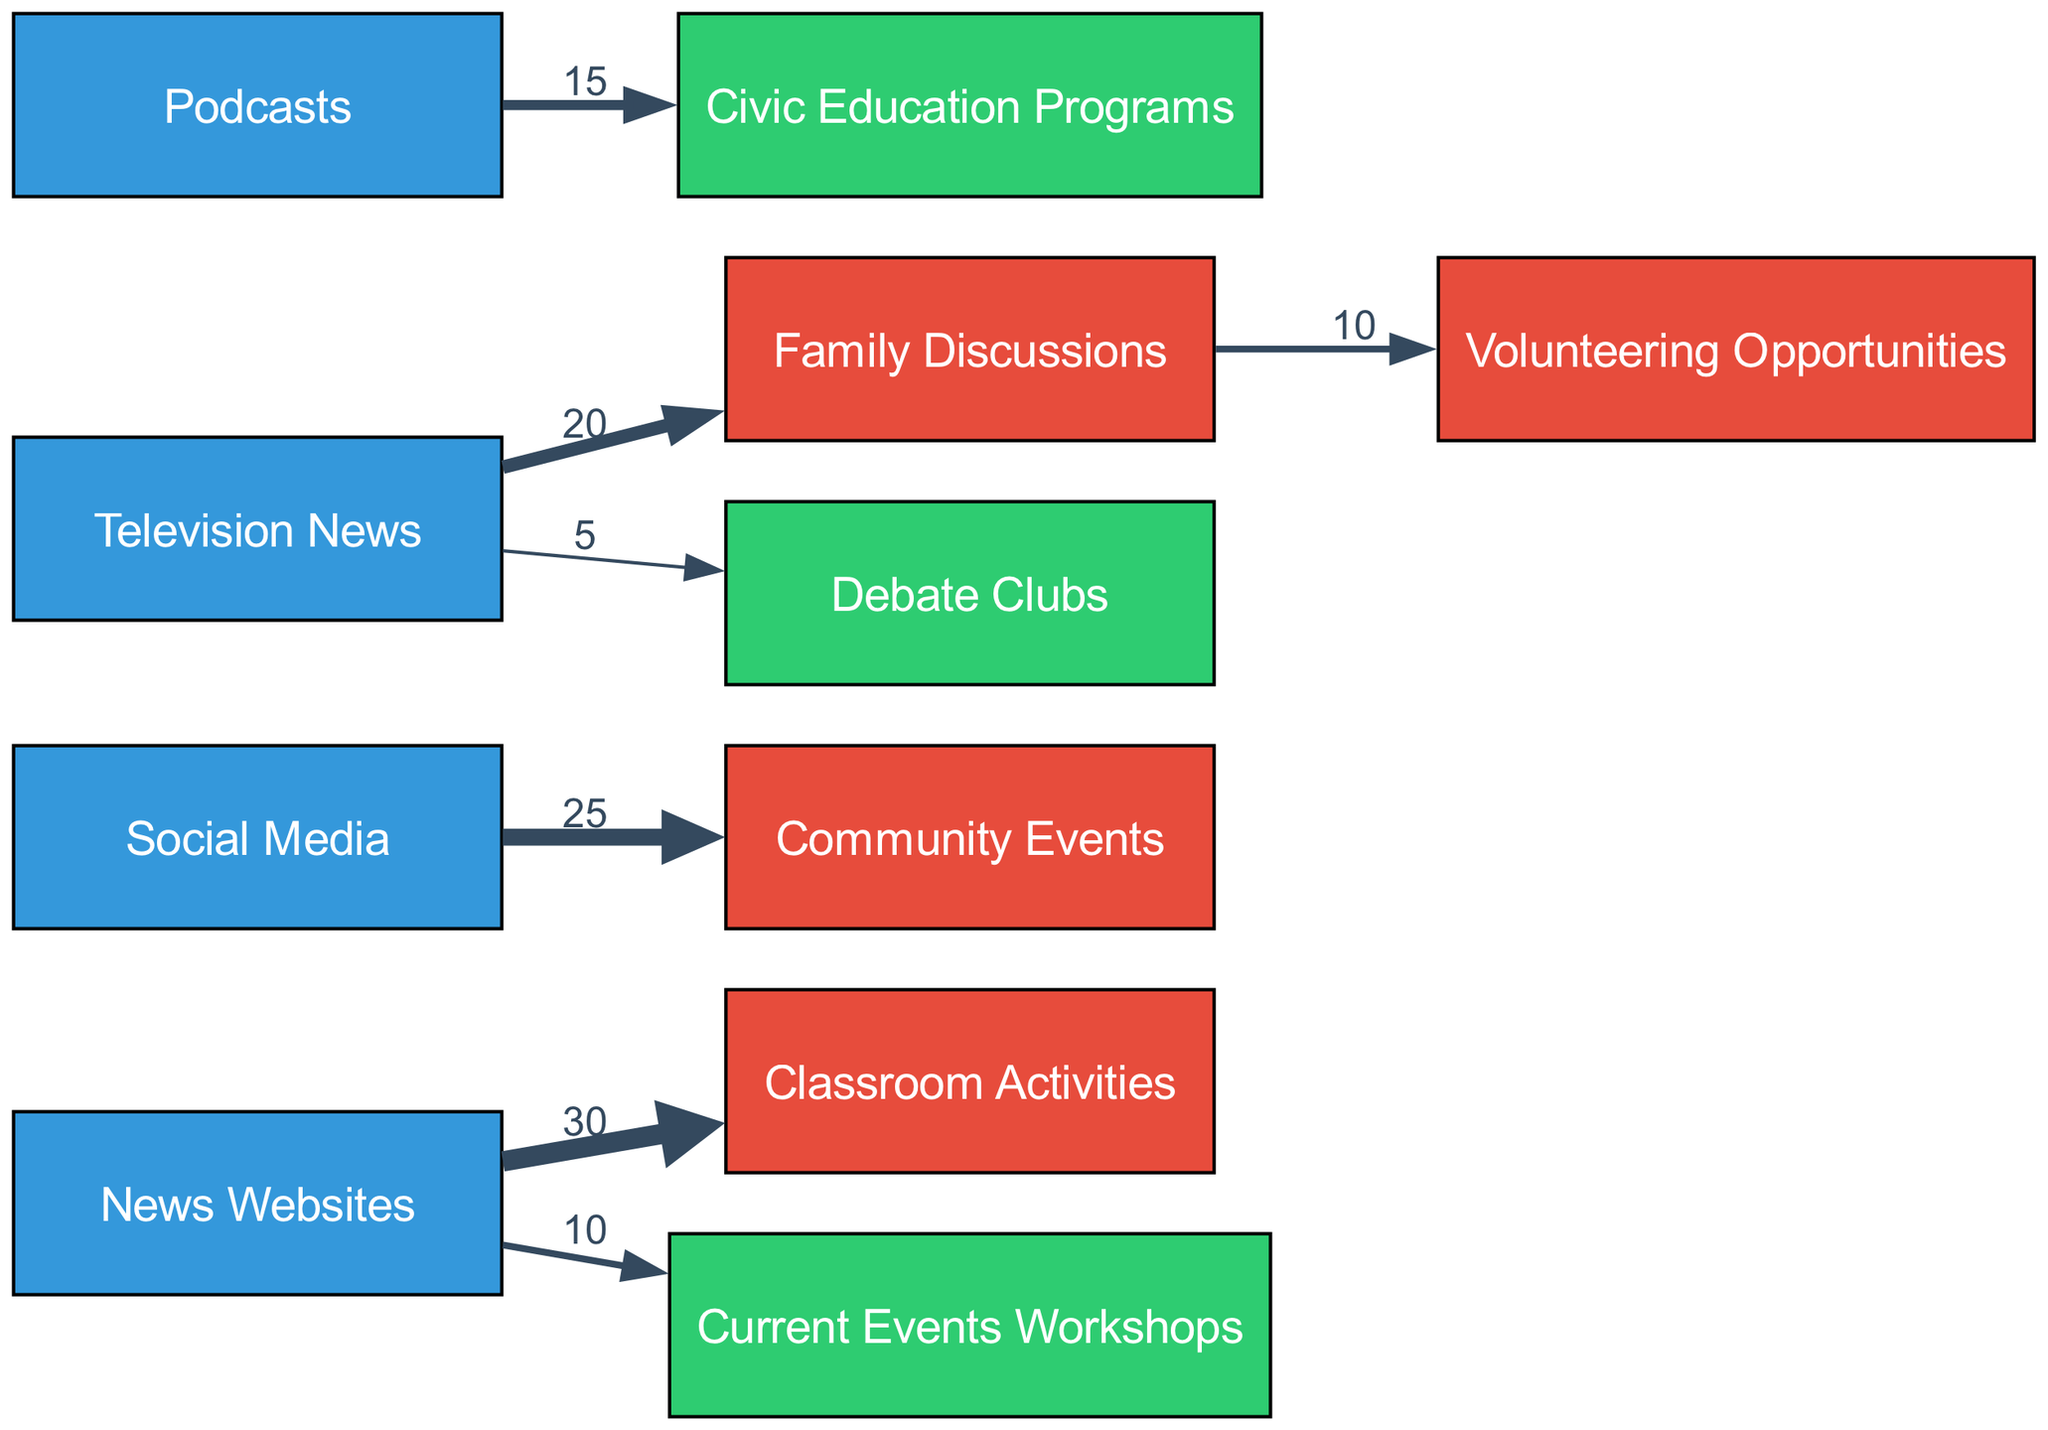what is the value connecting News Websites to Classroom Activities? In the diagram, the link from "News Websites" to "Classroom Activities" has a value label of 30, indicating that 30 units of media consumption flow from this source to this engagement type.
Answer: 30 how many engagement types are shown in the diagram? The diagram includes four engagement types: Classroom Activities, Community Events, Family Discussions, and Volunteering Opportunities. Therefore, by counting these unique nodes under the "Engagement" category, we find there are four engagement types.
Answer: 4 which source connects to the highest number of engagement activities? By examining the sources in the diagram, "News Websites" is linked to both "Classroom Activities" (30) and "Current Events Workshops" (10), totaling two engagement activities, while "Social Media," "Television News," and "Podcasts" are each connected to one or two activities. The highest number of connections to engagement activities is from "News Websites."
Answer: News Websites what is the total value of all connections to Family Discussions? The diagram shows that "Family Discussions" has inbound links from "Television News" (20) and outbound links to "Volunteering Opportunities" (10). To find the total value, we can sum these two values: 20 (inbound) + 10 (outbound) = 30.
Answer: 30 which source has the smallest link value to an engagement activity? Examining the links, the smallest value is from "Television News" to "Debate Clubs," which has a link value of 5, indicating this is the weakest connection in the diagram.
Answer: 5 how much media consumption flows from Social Media to Community Events? The link from "Social Media" to "Community Events" is labeled with a value of 25, representing the flow of media consumption from this source to this engagement type directly.
Answer: 25 which engagement type is linked to the most sources? Analyzing the engagement types, "Family Discussions" has connections only from "Television News" (20) and an outbound link to "Volunteering Opportunities" (10), linking it to one unique source. Therefore, none of the engagement types link to more than one source. Thus, no engagement type is linked to multiple sources in this specific dataset.
Answer: Family Discussions how many total links are present in the diagram? Count each individual link listed in the data: there are seven links connecting various sources to engagement types. Therefore, the total number of links present in the diagram is seven.
Answer: 7 